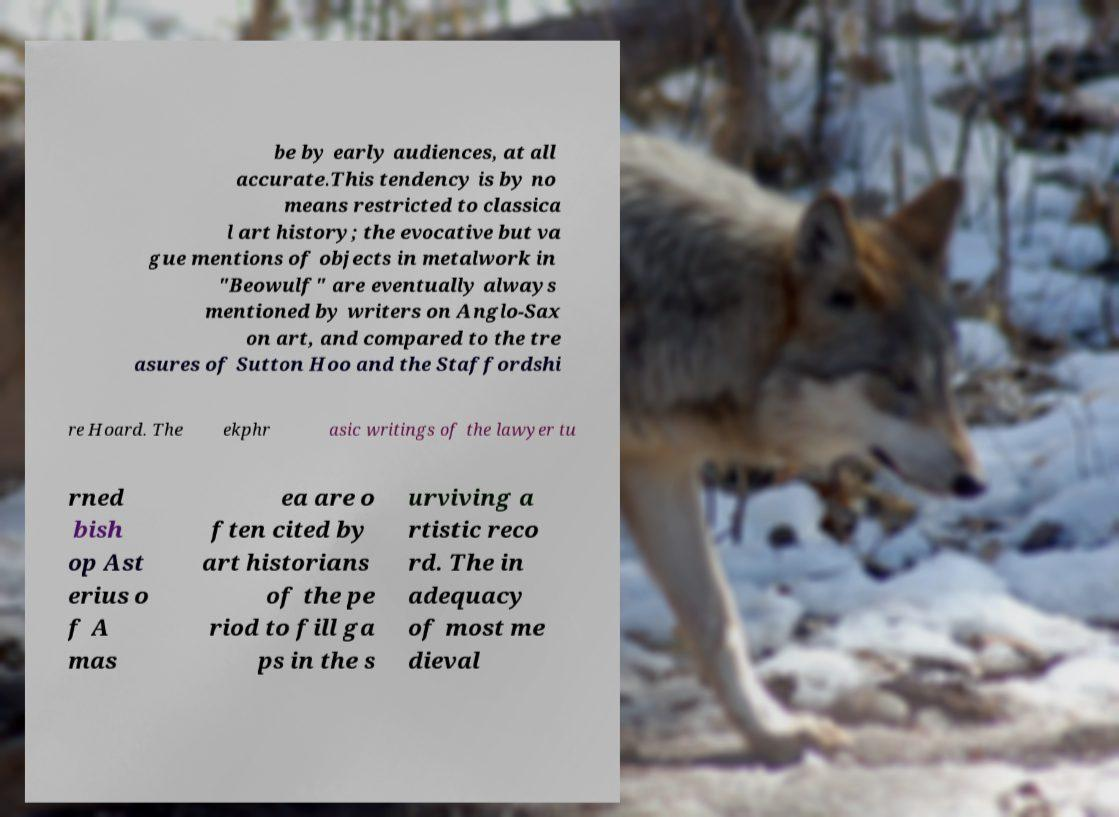Could you extract and type out the text from this image? be by early audiences, at all accurate.This tendency is by no means restricted to classica l art history; the evocative but va gue mentions of objects in metalwork in "Beowulf" are eventually always mentioned by writers on Anglo-Sax on art, and compared to the tre asures of Sutton Hoo and the Staffordshi re Hoard. The ekphr asic writings of the lawyer tu rned bish op Ast erius o f A mas ea are o ften cited by art historians of the pe riod to fill ga ps in the s urviving a rtistic reco rd. The in adequacy of most me dieval 